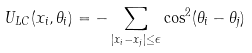<formula> <loc_0><loc_0><loc_500><loc_500>U _ { L C } ( x _ { i } , \theta _ { i } ) = - \sum _ { \left | x _ { i } - x _ { j } \right | \leq \epsilon } \cos ^ { 2 } ( \theta _ { i } - \theta _ { j } )</formula> 